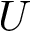<formula> <loc_0><loc_0><loc_500><loc_500>U</formula> 